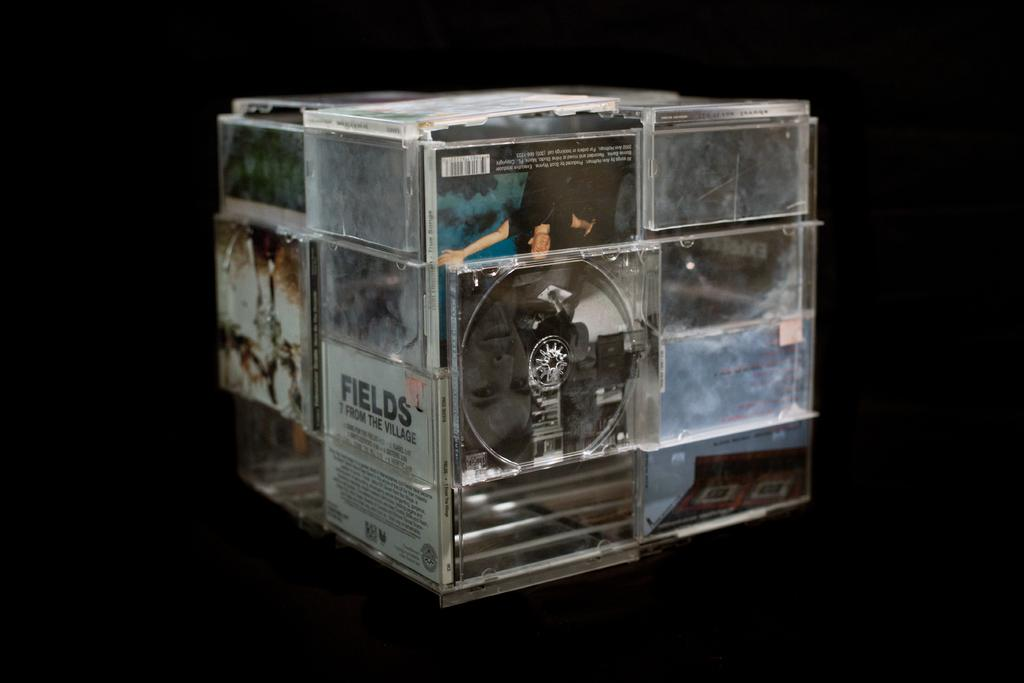<image>
Provide a brief description of the given image. A cube made of old CD cases including one from Fields. 